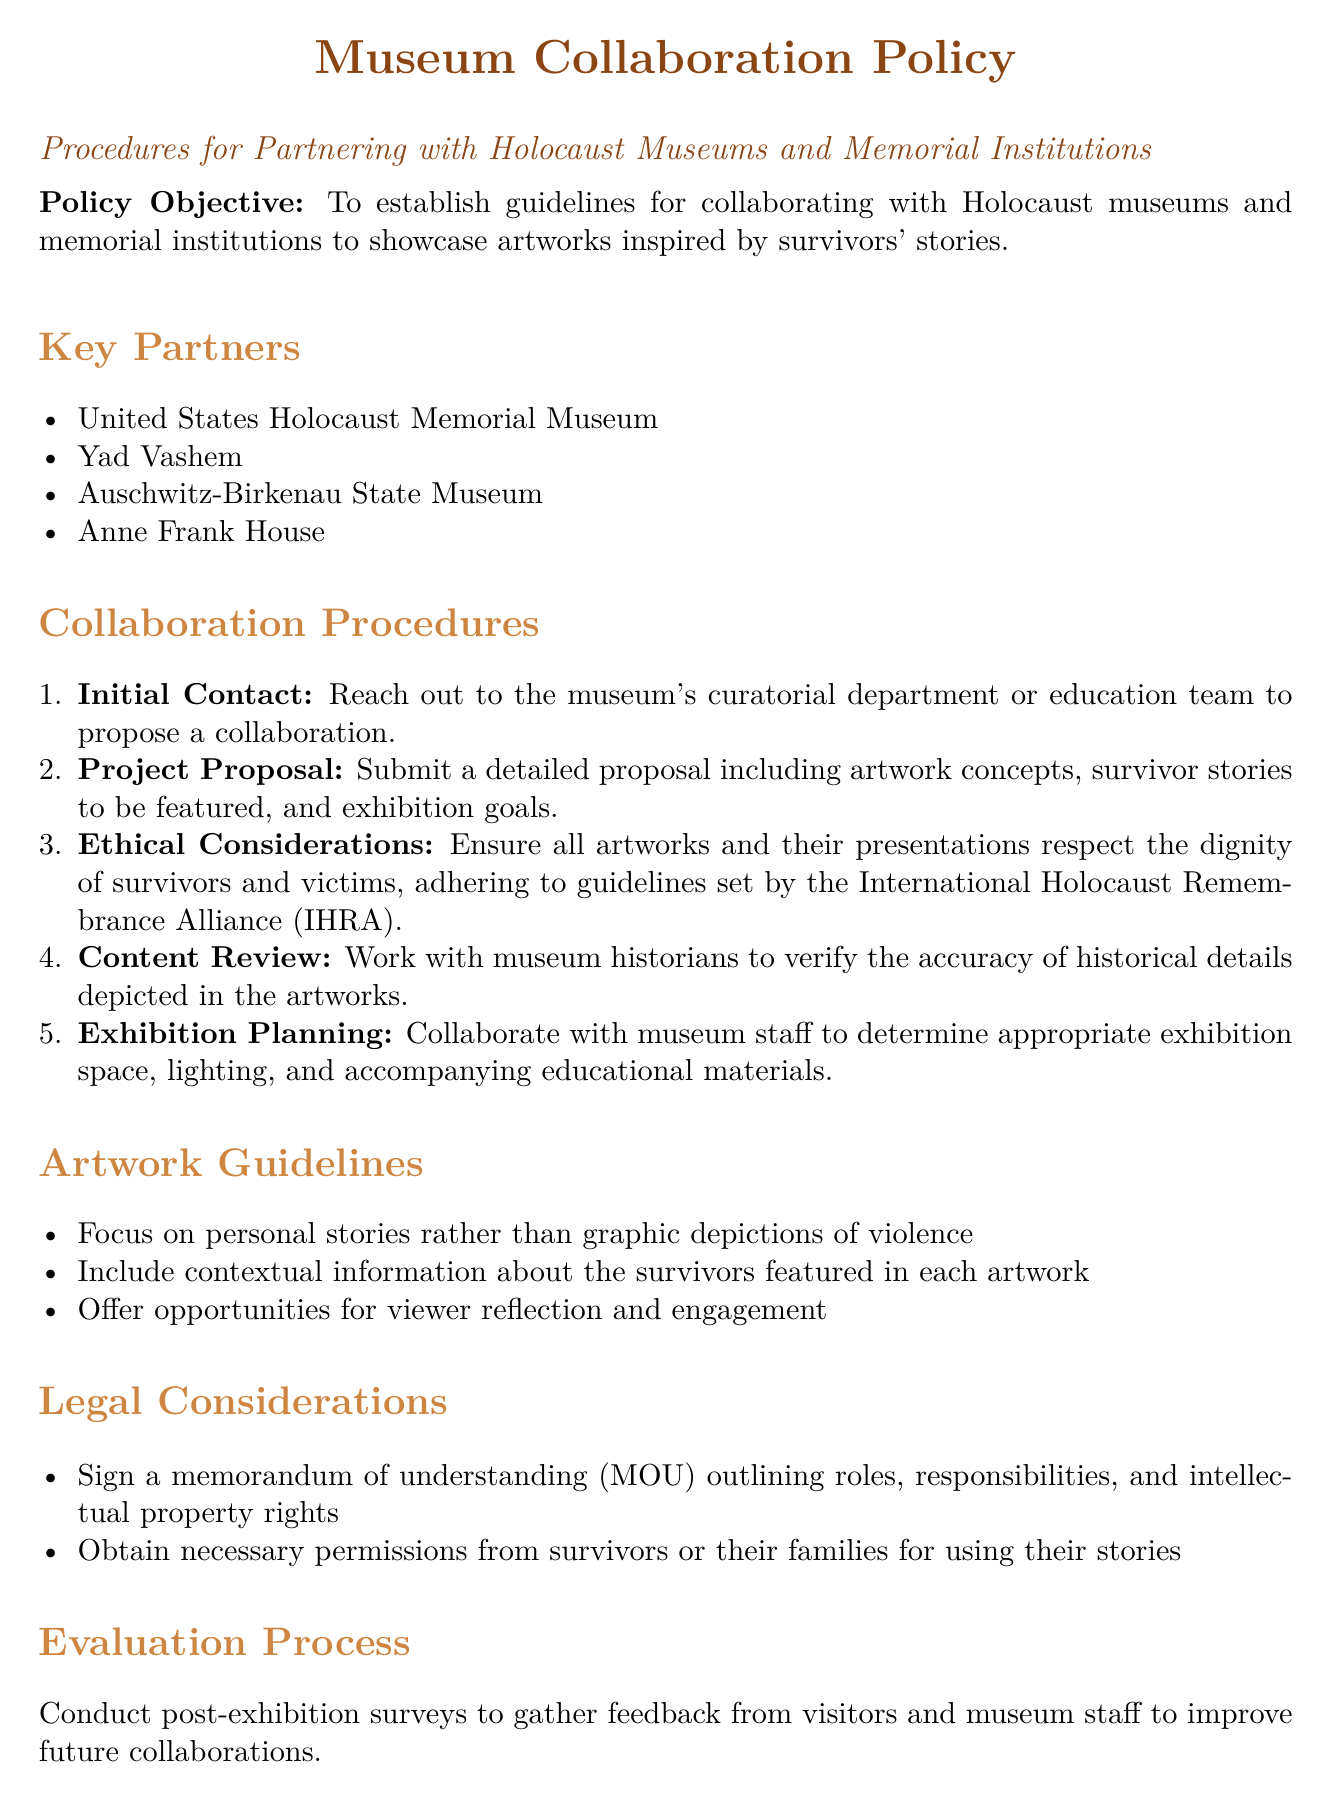What is the policy objective? The policy objective is to establish guidelines for collaborating with Holocaust museums and memorial institutions to showcase artworks inspired by survivors' stories.
Answer: To establish guidelines for collaborating with Holocaust museums and memorial institutions to showcase artworks inspired by survivors' stories What is the first step in the collaboration procedures? The document lists the collaboration procedures, starting with the initial contact.
Answer: Initial Contact Which organization is one of the key partners? The document names several key partners in collaboration, one of which is the United States Holocaust Memorial Museum.
Answer: United States Holocaust Memorial Museum What must be included in the project proposal? The project proposal must include details about artwork concepts, survivor stories, and exhibition goals.
Answer: Artwork concepts, survivor stories, and exhibition goals What must be signed to outline roles and responsibilities? The document states that a memorandum of understanding is required to outline roles and responsibilities.
Answer: Memorandum of understanding (MOU) 